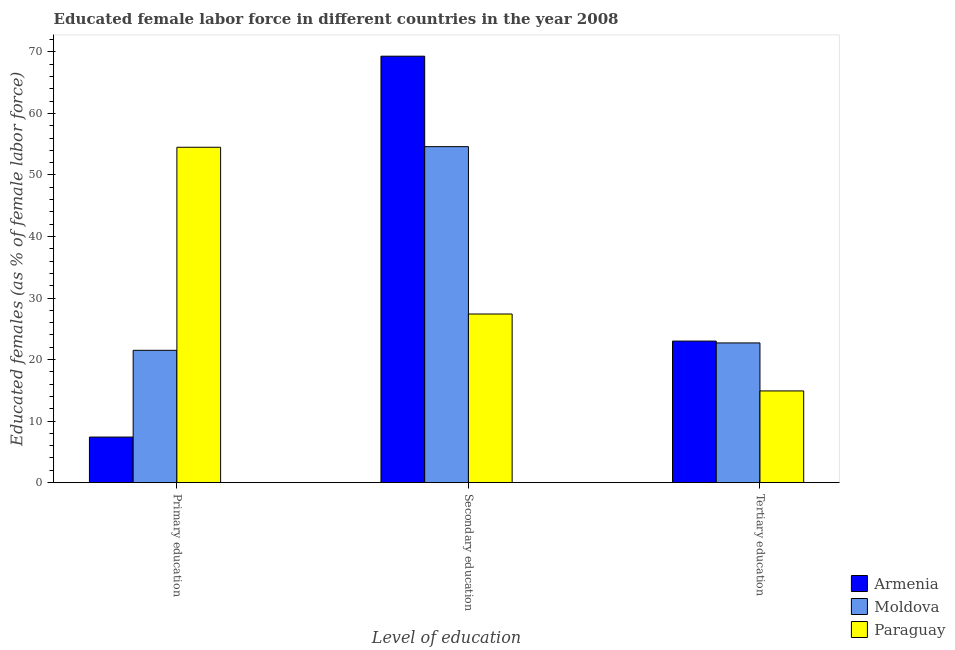How many groups of bars are there?
Your answer should be very brief. 3. How many bars are there on the 2nd tick from the left?
Offer a very short reply. 3. Across all countries, what is the minimum percentage of female labor force who received primary education?
Make the answer very short. 7.4. In which country was the percentage of female labor force who received primary education maximum?
Offer a very short reply. Paraguay. In which country was the percentage of female labor force who received primary education minimum?
Ensure brevity in your answer.  Armenia. What is the total percentage of female labor force who received secondary education in the graph?
Offer a very short reply. 151.3. What is the difference between the percentage of female labor force who received primary education in Armenia and that in Paraguay?
Provide a succinct answer. -47.1. What is the difference between the percentage of female labor force who received tertiary education in Moldova and the percentage of female labor force who received primary education in Armenia?
Offer a very short reply. 15.3. What is the average percentage of female labor force who received primary education per country?
Your answer should be compact. 27.8. What is the difference between the percentage of female labor force who received primary education and percentage of female labor force who received tertiary education in Armenia?
Give a very brief answer. -15.6. In how many countries, is the percentage of female labor force who received primary education greater than 4 %?
Make the answer very short. 3. What is the ratio of the percentage of female labor force who received tertiary education in Armenia to that in Paraguay?
Make the answer very short. 1.54. Is the percentage of female labor force who received secondary education in Moldova less than that in Armenia?
Offer a terse response. Yes. Is the difference between the percentage of female labor force who received secondary education in Armenia and Moldova greater than the difference between the percentage of female labor force who received primary education in Armenia and Moldova?
Your answer should be compact. Yes. What is the difference between the highest and the second highest percentage of female labor force who received secondary education?
Your answer should be very brief. 14.7. What is the difference between the highest and the lowest percentage of female labor force who received secondary education?
Your answer should be compact. 41.9. In how many countries, is the percentage of female labor force who received primary education greater than the average percentage of female labor force who received primary education taken over all countries?
Make the answer very short. 1. What does the 2nd bar from the left in Tertiary education represents?
Give a very brief answer. Moldova. What does the 1st bar from the right in Secondary education represents?
Provide a succinct answer. Paraguay. Are all the bars in the graph horizontal?
Provide a succinct answer. No. Does the graph contain any zero values?
Make the answer very short. No. Does the graph contain grids?
Your answer should be compact. No. What is the title of the graph?
Offer a very short reply. Educated female labor force in different countries in the year 2008. What is the label or title of the X-axis?
Offer a very short reply. Level of education. What is the label or title of the Y-axis?
Your answer should be very brief. Educated females (as % of female labor force). What is the Educated females (as % of female labor force) in Armenia in Primary education?
Your answer should be compact. 7.4. What is the Educated females (as % of female labor force) in Moldova in Primary education?
Ensure brevity in your answer.  21.5. What is the Educated females (as % of female labor force) in Paraguay in Primary education?
Your answer should be very brief. 54.5. What is the Educated females (as % of female labor force) in Armenia in Secondary education?
Ensure brevity in your answer.  69.3. What is the Educated females (as % of female labor force) of Moldova in Secondary education?
Make the answer very short. 54.6. What is the Educated females (as % of female labor force) in Paraguay in Secondary education?
Offer a terse response. 27.4. What is the Educated females (as % of female labor force) of Moldova in Tertiary education?
Provide a short and direct response. 22.7. What is the Educated females (as % of female labor force) of Paraguay in Tertiary education?
Your answer should be very brief. 14.9. Across all Level of education, what is the maximum Educated females (as % of female labor force) of Armenia?
Give a very brief answer. 69.3. Across all Level of education, what is the maximum Educated females (as % of female labor force) in Moldova?
Offer a very short reply. 54.6. Across all Level of education, what is the maximum Educated females (as % of female labor force) in Paraguay?
Your response must be concise. 54.5. Across all Level of education, what is the minimum Educated females (as % of female labor force) of Armenia?
Give a very brief answer. 7.4. Across all Level of education, what is the minimum Educated females (as % of female labor force) in Moldova?
Ensure brevity in your answer.  21.5. Across all Level of education, what is the minimum Educated females (as % of female labor force) of Paraguay?
Provide a succinct answer. 14.9. What is the total Educated females (as % of female labor force) of Armenia in the graph?
Your answer should be very brief. 99.7. What is the total Educated females (as % of female labor force) of Moldova in the graph?
Offer a very short reply. 98.8. What is the total Educated females (as % of female labor force) in Paraguay in the graph?
Keep it short and to the point. 96.8. What is the difference between the Educated females (as % of female labor force) in Armenia in Primary education and that in Secondary education?
Your answer should be compact. -61.9. What is the difference between the Educated females (as % of female labor force) in Moldova in Primary education and that in Secondary education?
Your answer should be compact. -33.1. What is the difference between the Educated females (as % of female labor force) of Paraguay in Primary education and that in Secondary education?
Provide a succinct answer. 27.1. What is the difference between the Educated females (as % of female labor force) in Armenia in Primary education and that in Tertiary education?
Keep it short and to the point. -15.6. What is the difference between the Educated females (as % of female labor force) of Paraguay in Primary education and that in Tertiary education?
Give a very brief answer. 39.6. What is the difference between the Educated females (as % of female labor force) in Armenia in Secondary education and that in Tertiary education?
Your answer should be compact. 46.3. What is the difference between the Educated females (as % of female labor force) of Moldova in Secondary education and that in Tertiary education?
Your answer should be very brief. 31.9. What is the difference between the Educated females (as % of female labor force) in Paraguay in Secondary education and that in Tertiary education?
Ensure brevity in your answer.  12.5. What is the difference between the Educated females (as % of female labor force) in Armenia in Primary education and the Educated females (as % of female labor force) in Moldova in Secondary education?
Keep it short and to the point. -47.2. What is the difference between the Educated females (as % of female labor force) of Armenia in Primary education and the Educated females (as % of female labor force) of Paraguay in Secondary education?
Your answer should be very brief. -20. What is the difference between the Educated females (as % of female labor force) in Armenia in Primary education and the Educated females (as % of female labor force) in Moldova in Tertiary education?
Your answer should be very brief. -15.3. What is the difference between the Educated females (as % of female labor force) in Armenia in Secondary education and the Educated females (as % of female labor force) in Moldova in Tertiary education?
Your response must be concise. 46.6. What is the difference between the Educated females (as % of female labor force) of Armenia in Secondary education and the Educated females (as % of female labor force) of Paraguay in Tertiary education?
Your answer should be very brief. 54.4. What is the difference between the Educated females (as % of female labor force) in Moldova in Secondary education and the Educated females (as % of female labor force) in Paraguay in Tertiary education?
Ensure brevity in your answer.  39.7. What is the average Educated females (as % of female labor force) in Armenia per Level of education?
Offer a very short reply. 33.23. What is the average Educated females (as % of female labor force) in Moldova per Level of education?
Your answer should be compact. 32.93. What is the average Educated females (as % of female labor force) in Paraguay per Level of education?
Make the answer very short. 32.27. What is the difference between the Educated females (as % of female labor force) in Armenia and Educated females (as % of female labor force) in Moldova in Primary education?
Make the answer very short. -14.1. What is the difference between the Educated females (as % of female labor force) of Armenia and Educated females (as % of female labor force) of Paraguay in Primary education?
Make the answer very short. -47.1. What is the difference between the Educated females (as % of female labor force) of Moldova and Educated females (as % of female labor force) of Paraguay in Primary education?
Offer a very short reply. -33. What is the difference between the Educated females (as % of female labor force) of Armenia and Educated females (as % of female labor force) of Moldova in Secondary education?
Offer a terse response. 14.7. What is the difference between the Educated females (as % of female labor force) of Armenia and Educated females (as % of female labor force) of Paraguay in Secondary education?
Make the answer very short. 41.9. What is the difference between the Educated females (as % of female labor force) of Moldova and Educated females (as % of female labor force) of Paraguay in Secondary education?
Your answer should be compact. 27.2. What is the difference between the Educated females (as % of female labor force) in Armenia and Educated females (as % of female labor force) in Moldova in Tertiary education?
Make the answer very short. 0.3. What is the difference between the Educated females (as % of female labor force) of Armenia and Educated females (as % of female labor force) of Paraguay in Tertiary education?
Ensure brevity in your answer.  8.1. What is the difference between the Educated females (as % of female labor force) of Moldova and Educated females (as % of female labor force) of Paraguay in Tertiary education?
Your answer should be compact. 7.8. What is the ratio of the Educated females (as % of female labor force) in Armenia in Primary education to that in Secondary education?
Ensure brevity in your answer.  0.11. What is the ratio of the Educated females (as % of female labor force) of Moldova in Primary education to that in Secondary education?
Your response must be concise. 0.39. What is the ratio of the Educated females (as % of female labor force) of Paraguay in Primary education to that in Secondary education?
Ensure brevity in your answer.  1.99. What is the ratio of the Educated females (as % of female labor force) in Armenia in Primary education to that in Tertiary education?
Keep it short and to the point. 0.32. What is the ratio of the Educated females (as % of female labor force) in Moldova in Primary education to that in Tertiary education?
Keep it short and to the point. 0.95. What is the ratio of the Educated females (as % of female labor force) of Paraguay in Primary education to that in Tertiary education?
Provide a short and direct response. 3.66. What is the ratio of the Educated females (as % of female labor force) in Armenia in Secondary education to that in Tertiary education?
Your answer should be very brief. 3.01. What is the ratio of the Educated females (as % of female labor force) in Moldova in Secondary education to that in Tertiary education?
Your response must be concise. 2.41. What is the ratio of the Educated females (as % of female labor force) of Paraguay in Secondary education to that in Tertiary education?
Offer a terse response. 1.84. What is the difference between the highest and the second highest Educated females (as % of female labor force) of Armenia?
Offer a very short reply. 46.3. What is the difference between the highest and the second highest Educated females (as % of female labor force) of Moldova?
Offer a very short reply. 31.9. What is the difference between the highest and the second highest Educated females (as % of female labor force) of Paraguay?
Offer a terse response. 27.1. What is the difference between the highest and the lowest Educated females (as % of female labor force) in Armenia?
Ensure brevity in your answer.  61.9. What is the difference between the highest and the lowest Educated females (as % of female labor force) of Moldova?
Give a very brief answer. 33.1. What is the difference between the highest and the lowest Educated females (as % of female labor force) of Paraguay?
Provide a succinct answer. 39.6. 